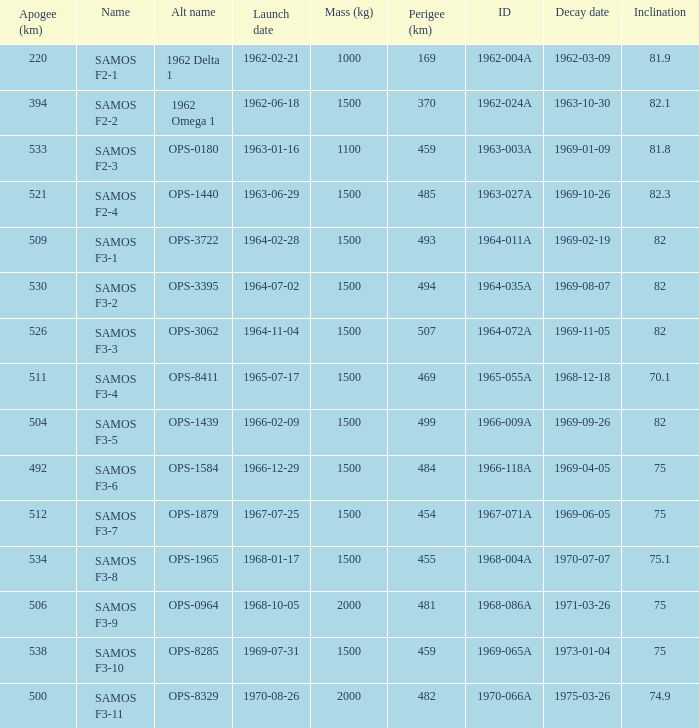What is the maximum apogee for samos f3-3? 526.0. 